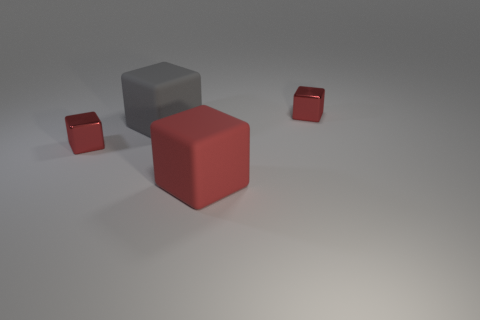What time of day or lighting conditions does the setting imply? The image seems to be lit with a neutral, diffused light suggestive of an overcast day or soft artificial lighting, often used in a studio environment. Shadows are minimal and soft-edged, indicating the light source is not intense or direct. 